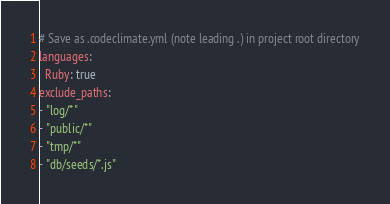<code> <loc_0><loc_0><loc_500><loc_500><_YAML_># Save as .codeclimate.yml (note leading .) in project root directory
languages:
  Ruby: true
exclude_paths:
- "log/*"
- "public/*"
- "tmp/*"
- "db/seeds/*.js"</code> 